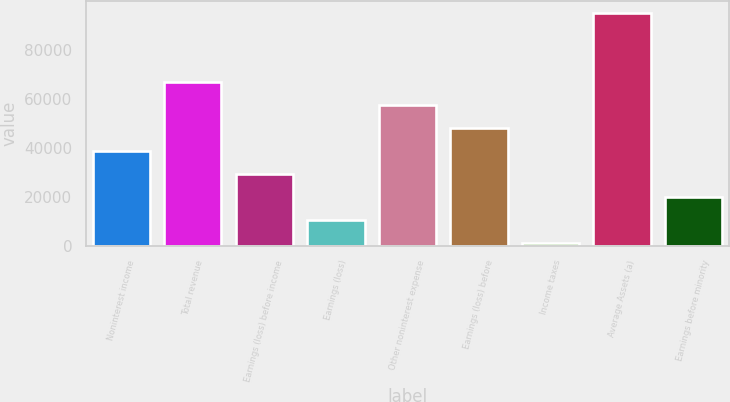Convert chart. <chart><loc_0><loc_0><loc_500><loc_500><bar_chart><fcel>Noninterest income<fcel>Total revenue<fcel>Earnings (loss) before income<fcel>Earnings (loss)<fcel>Other noninterest expense<fcel>Earnings (loss) before<fcel>Income taxes<fcel>Average Assets (a)<fcel>Earnings before minority<nl><fcel>38822.6<fcel>66917.3<fcel>29457.7<fcel>10727.9<fcel>57552.4<fcel>48187.5<fcel>1363<fcel>95012<fcel>20092.8<nl></chart> 